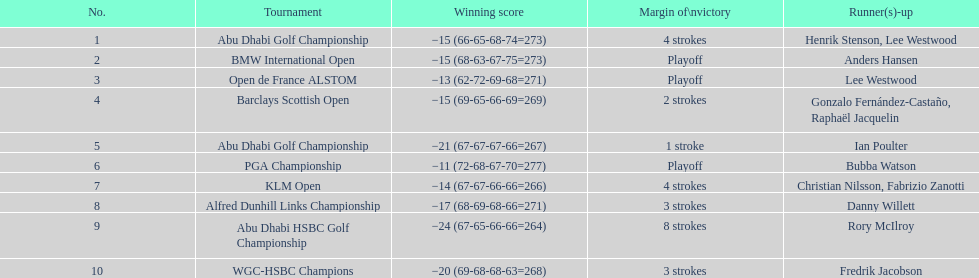How many more strokes were in the klm open than the barclays scottish open? 2 strokes. 